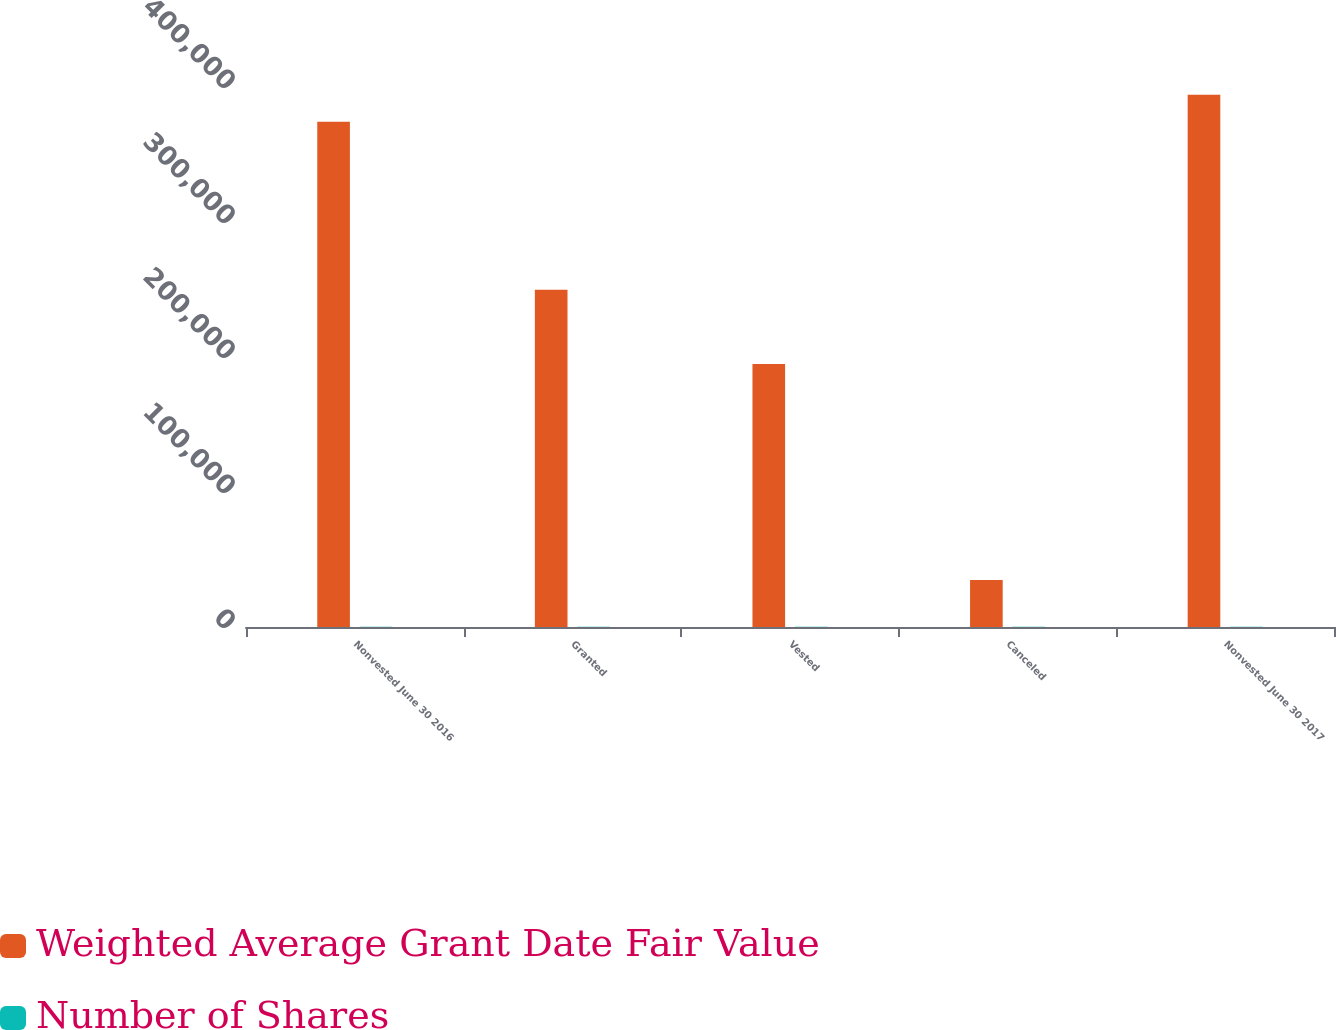Convert chart to OTSL. <chart><loc_0><loc_0><loc_500><loc_500><stacked_bar_chart><ecel><fcel>Nonvested June 30 2016<fcel>Granted<fcel>Vested<fcel>Canceled<fcel>Nonvested June 30 2017<nl><fcel>Weighted Average Grant Date Fair Value<fcel>374168<fcel>249892<fcel>194844<fcel>34887<fcel>394329<nl><fcel>Number of Shares<fcel>111.82<fcel>128.3<fcel>110.74<fcel>133.12<fcel>120.92<nl></chart> 